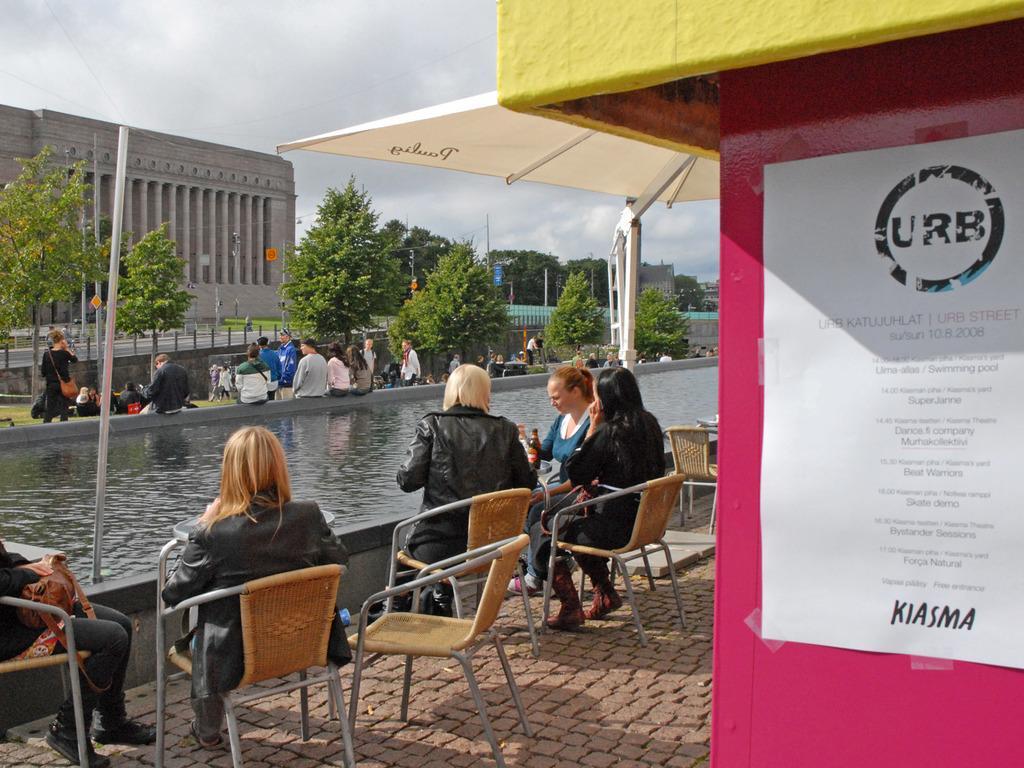Please provide a concise description of this image. In this image we can see a five woman sitting on a chair. Here we can see a water floating. Here we can see a few people. Here we can see a building , trees and a sky. 